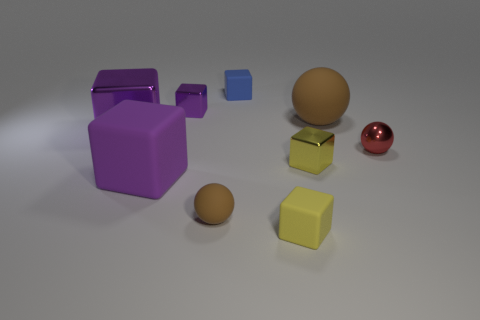What size is the other rubber sphere that is the same color as the tiny rubber sphere? large 